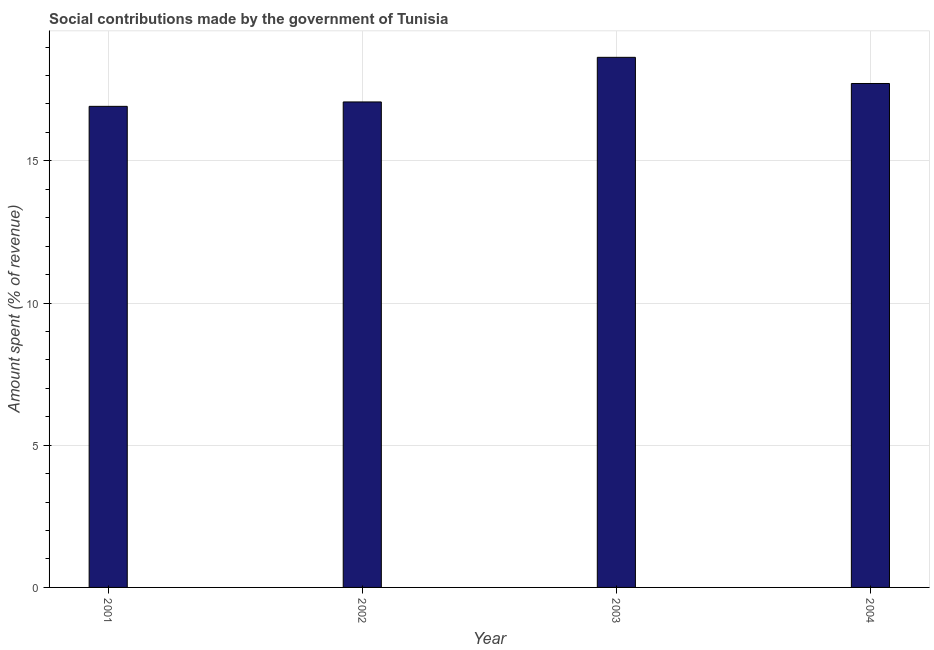Does the graph contain any zero values?
Your answer should be compact. No. Does the graph contain grids?
Offer a very short reply. Yes. What is the title of the graph?
Ensure brevity in your answer.  Social contributions made by the government of Tunisia. What is the label or title of the X-axis?
Offer a very short reply. Year. What is the label or title of the Y-axis?
Make the answer very short. Amount spent (% of revenue). What is the amount spent in making social contributions in 2003?
Your answer should be compact. 18.64. Across all years, what is the maximum amount spent in making social contributions?
Your answer should be very brief. 18.64. Across all years, what is the minimum amount spent in making social contributions?
Make the answer very short. 16.92. In which year was the amount spent in making social contributions maximum?
Ensure brevity in your answer.  2003. In which year was the amount spent in making social contributions minimum?
Make the answer very short. 2001. What is the sum of the amount spent in making social contributions?
Offer a terse response. 70.35. What is the difference between the amount spent in making social contributions in 2001 and 2002?
Your response must be concise. -0.15. What is the average amount spent in making social contributions per year?
Provide a succinct answer. 17.59. What is the median amount spent in making social contributions?
Your response must be concise. 17.4. What is the ratio of the amount spent in making social contributions in 2002 to that in 2003?
Provide a succinct answer. 0.92. Is the amount spent in making social contributions in 2003 less than that in 2004?
Make the answer very short. No. Is the sum of the amount spent in making social contributions in 2003 and 2004 greater than the maximum amount spent in making social contributions across all years?
Provide a short and direct response. Yes. What is the difference between the highest and the lowest amount spent in making social contributions?
Provide a short and direct response. 1.72. What is the difference between two consecutive major ticks on the Y-axis?
Offer a very short reply. 5. Are the values on the major ticks of Y-axis written in scientific E-notation?
Offer a very short reply. No. What is the Amount spent (% of revenue) of 2001?
Keep it short and to the point. 16.92. What is the Amount spent (% of revenue) in 2002?
Keep it short and to the point. 17.07. What is the Amount spent (% of revenue) in 2003?
Offer a very short reply. 18.64. What is the Amount spent (% of revenue) of 2004?
Offer a very short reply. 17.72. What is the difference between the Amount spent (% of revenue) in 2001 and 2002?
Give a very brief answer. -0.15. What is the difference between the Amount spent (% of revenue) in 2001 and 2003?
Your answer should be very brief. -1.72. What is the difference between the Amount spent (% of revenue) in 2001 and 2004?
Offer a terse response. -0.8. What is the difference between the Amount spent (% of revenue) in 2002 and 2003?
Your response must be concise. -1.57. What is the difference between the Amount spent (% of revenue) in 2002 and 2004?
Your answer should be compact. -0.65. What is the difference between the Amount spent (% of revenue) in 2003 and 2004?
Your answer should be compact. 0.92. What is the ratio of the Amount spent (% of revenue) in 2001 to that in 2003?
Your response must be concise. 0.91. What is the ratio of the Amount spent (% of revenue) in 2001 to that in 2004?
Your response must be concise. 0.95. What is the ratio of the Amount spent (% of revenue) in 2002 to that in 2003?
Your answer should be very brief. 0.92. What is the ratio of the Amount spent (% of revenue) in 2002 to that in 2004?
Your answer should be very brief. 0.96. What is the ratio of the Amount spent (% of revenue) in 2003 to that in 2004?
Ensure brevity in your answer.  1.05. 